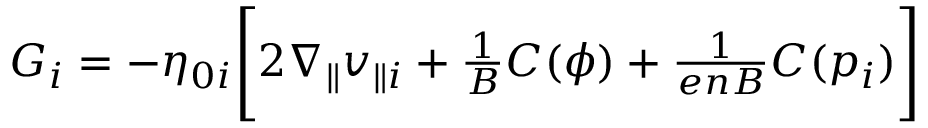Convert formula to latex. <formula><loc_0><loc_0><loc_500><loc_500>\begin{array} { r } { G _ { i } = - \eta _ { 0 i } \left [ 2 \nabla _ { \| } v _ { \| i } + \frac { 1 } { B } C ( \phi ) + \frac { 1 } { e n B } C ( p _ { i } ) \right ] } \end{array}</formula> 